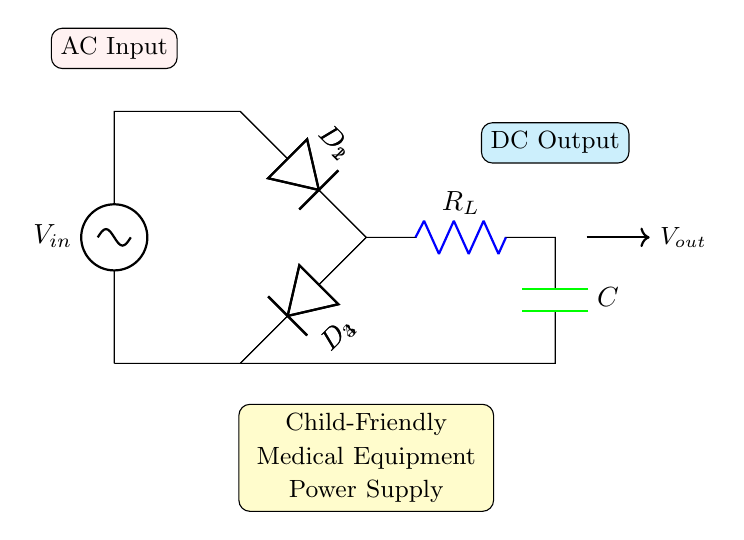What is the input voltage of the circuit? The input voltage is labeled as V input in the circuit diagram, indicating where the alternating current is supplied.
Answer: V input What are the components used in the rectifier? The components are two types of diodes (D1, D2, D3, D4) which are used for rectification, a load resistor (R_L), and a capacitor (C) for smoothing the output.
Answer: Diodes, resistor, capacitor How many diodes are present in the circuit? The circuit shows four diodes labeled D1, D2, D3, and D4, which are part of the full-wave bridge rectifier configuration.
Answer: Four What is the purpose of the capacitor in the circuit? The capacitor smooths the output voltage by filtering the rectified signal, reducing voltage fluctuations for more stable direct current.
Answer: Smoothing Why do we use a full-wave bridge rectifier instead of a half-wave rectifier? The full-wave bridge rectifier allows both halves of the AC waveform to be used, producing a more efficient and higher output voltage compared to a half-wave rectifier that only uses one half.
Answer: Higher efficiency What type of output does this circuit provide? The circuit provides direct current (DC) output after rectification of the alternating current input, making it suitable for powering medical equipment.
Answer: DC output 